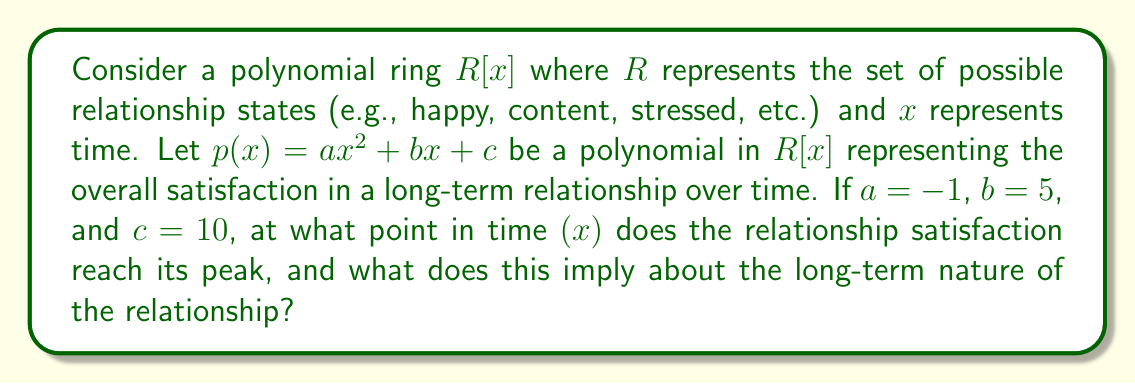Give your solution to this math problem. To solve this problem, we'll follow these steps:

1) The polynomial given is $p(x) = -x^2 + 5x + 10$. This is a quadratic function that represents relationship satisfaction over time.

2) To find the peak of a quadratic function, we need to find its vertex. For a quadratic function in the form $ax^2 + bx + c$, the x-coordinate of the vertex is given by $x = -\frac{b}{2a}$.

3) In this case, $a = -1$ and $b = 5$. Let's substitute these values:

   $x = -\frac{5}{2(-1)} = \frac{5}{2} = 2.5$

4) This means the relationship satisfaction reaches its peak at $x = 2.5$ time units.

5) To interpret this in the context of long-term relationships:
   - The negative $a$ value indicates that satisfaction eventually decreases over time.
   - The peak at 2.5 time units suggests that the "honeymoon phase" or peak satisfaction occurs relatively early in the relationship.
   - After this peak, the satisfaction gradually declines, which could represent the challenges and routine that often develop in long-term relationships.

6) This model implies that maintaining high satisfaction in a long-term relationship requires active effort to counteract the natural tendency for satisfaction to decline over time.
Answer: The relationship satisfaction reaches its peak at $x = 2.5$ time units. This implies that in this model, relationship satisfaction increases initially, peaks relatively early, and then gradually declines over the long term, highlighting the need for continuous effort to maintain satisfaction in long-term relationships. 